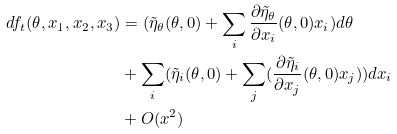<formula> <loc_0><loc_0><loc_500><loc_500>d f _ { t } ( \theta , x _ { 1 } , x _ { 2 } , x _ { 3 } ) & = ( \tilde { \eta } _ { \theta } ( \theta , 0 ) + \sum _ { i } \frac { \partial \tilde { \eta } _ { \theta } } { \partial x _ { i } } ( \theta , 0 ) x _ { i } ) d \theta \\ & + \sum _ { i } ( \tilde { \eta } _ { i } ( \theta , 0 ) + \sum _ { j } ( \frac { \partial \tilde { \eta } _ { i } } { \partial x _ { j } } ( \theta , 0 ) x _ { j } ) ) d x _ { i } \\ & + O ( x ^ { 2 } )</formula> 